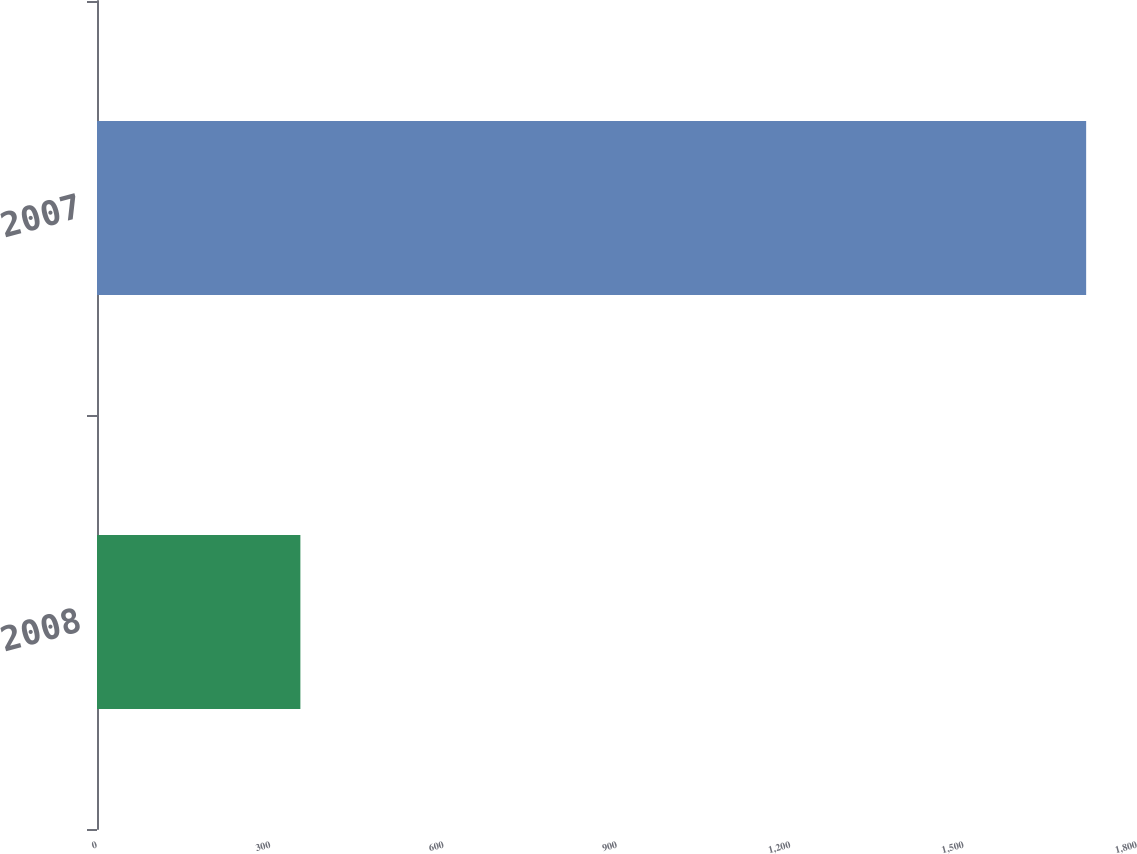<chart> <loc_0><loc_0><loc_500><loc_500><bar_chart><fcel>2008<fcel>2007<nl><fcel>352<fcel>1712<nl></chart> 